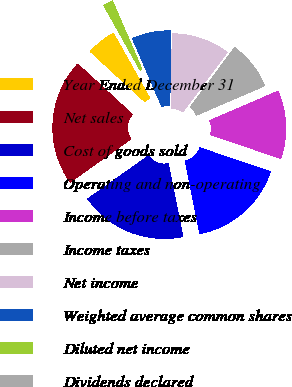Convert chart to OTSL. <chart><loc_0><loc_0><loc_500><loc_500><pie_chart><fcel>Year Ended December 31<fcel>Net sales<fcel>Cost of goods sold<fcel>Operating and non-operating<fcel>Income before taxes<fcel>Income taxes<fcel>Net income<fcel>Weighted average common shares<fcel>Diluted net income<fcel>Dividends declared<nl><fcel>5.0%<fcel>21.67%<fcel>18.33%<fcel>16.67%<fcel>11.67%<fcel>8.33%<fcel>10.0%<fcel>6.67%<fcel>1.67%<fcel>0.0%<nl></chart> 